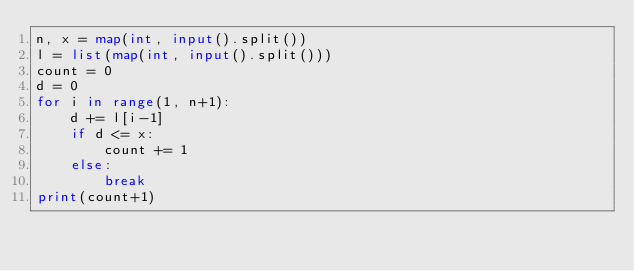Convert code to text. <code><loc_0><loc_0><loc_500><loc_500><_Python_>n, x = map(int, input().split())
l = list(map(int, input().split()))
count = 0
d = 0
for i in range(1, n+1):
    d += l[i-1]
    if d <= x:
        count += 1
    else:
        break
print(count+1)</code> 